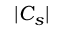<formula> <loc_0><loc_0><loc_500><loc_500>| C _ { s } |</formula> 